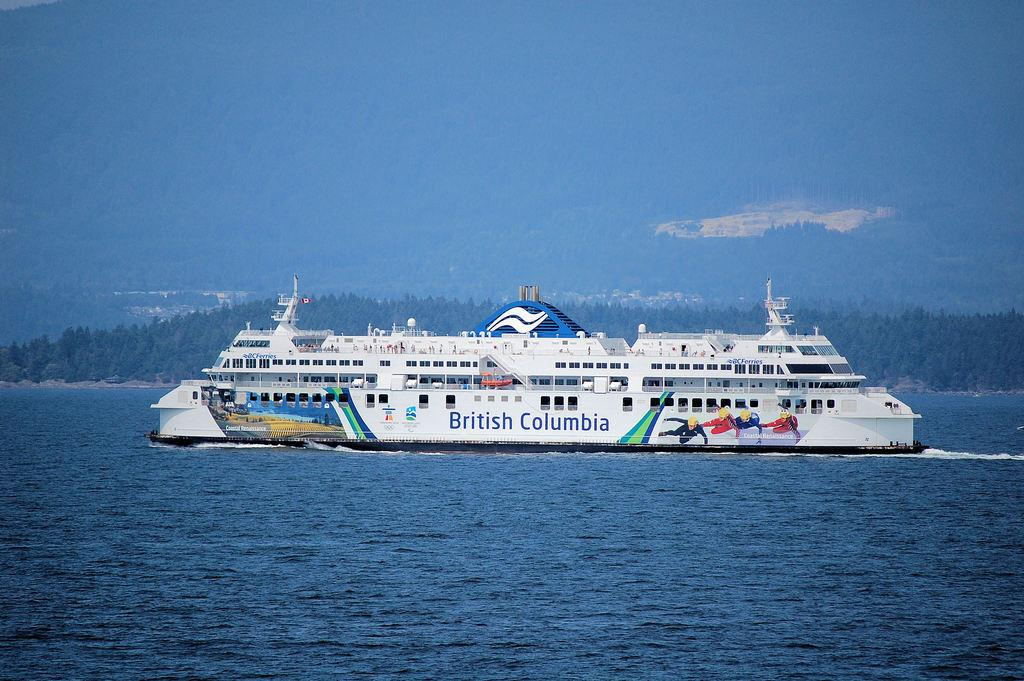<image>
Provide a brief description of the given image. A British Columbia cruise ship is in the water on a clear day. 